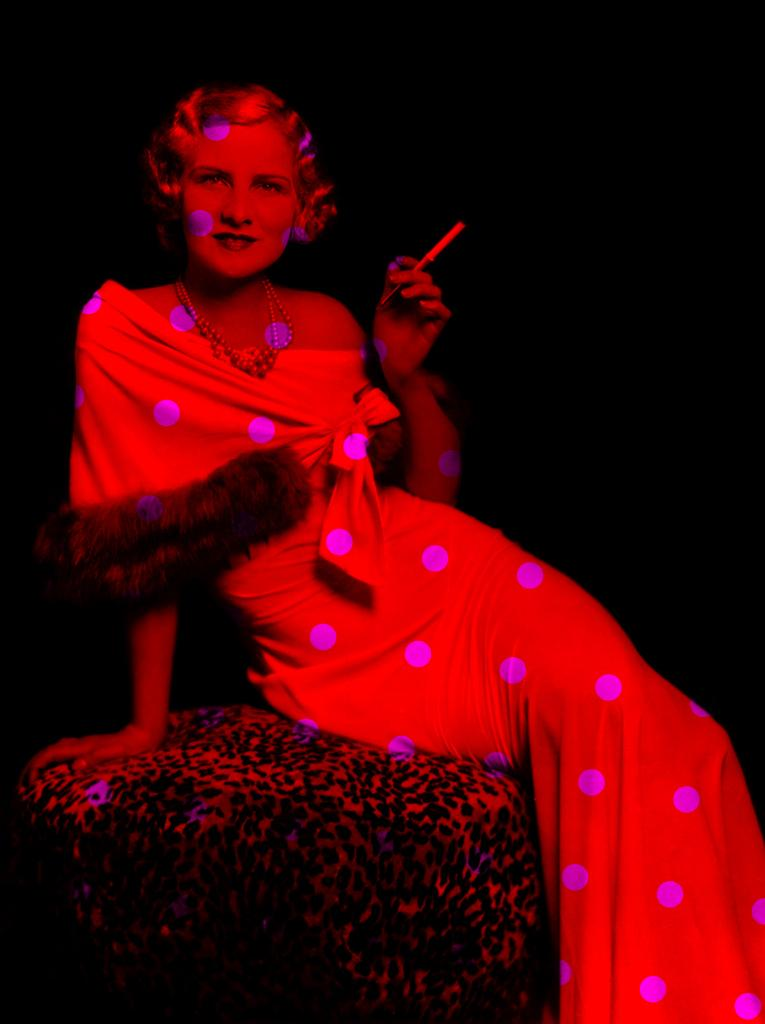Who is the main subject in the image? There is a woman in the image. What is the woman doing in the image? The woman is sitting on a table. What object is the woman holding in the image? The woman is holding a pen. What type of yam is the woman using to write on the table? There is no yam present in the image, and the woman is not using any object to write on the table. 